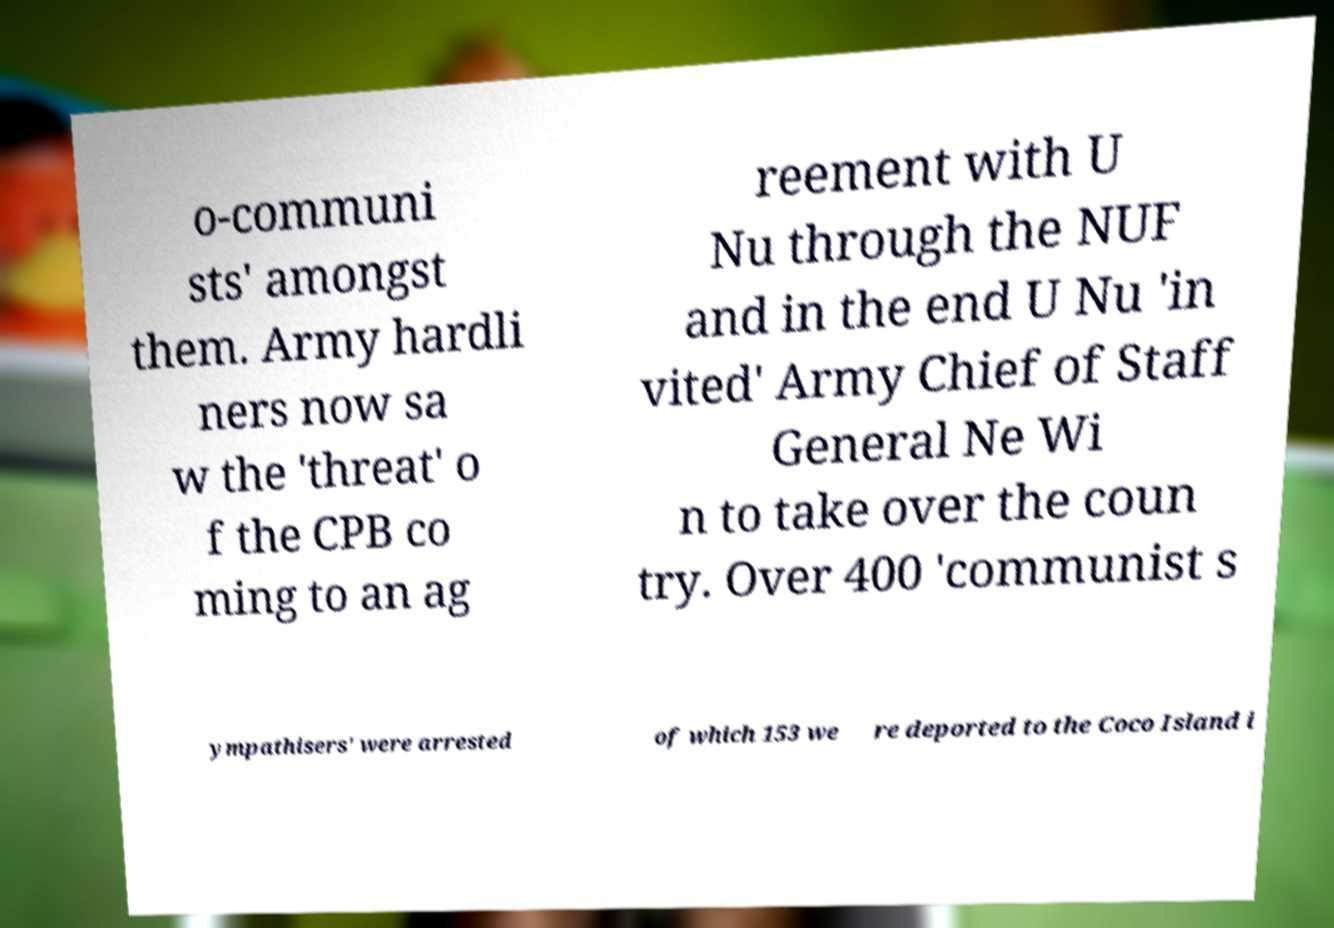I need the written content from this picture converted into text. Can you do that? o-communi sts' amongst them. Army hardli ners now sa w the 'threat' o f the CPB co ming to an ag reement with U Nu through the NUF and in the end U Nu 'in vited' Army Chief of Staff General Ne Wi n to take over the coun try. Over 400 'communist s ympathisers' were arrested of which 153 we re deported to the Coco Island i 